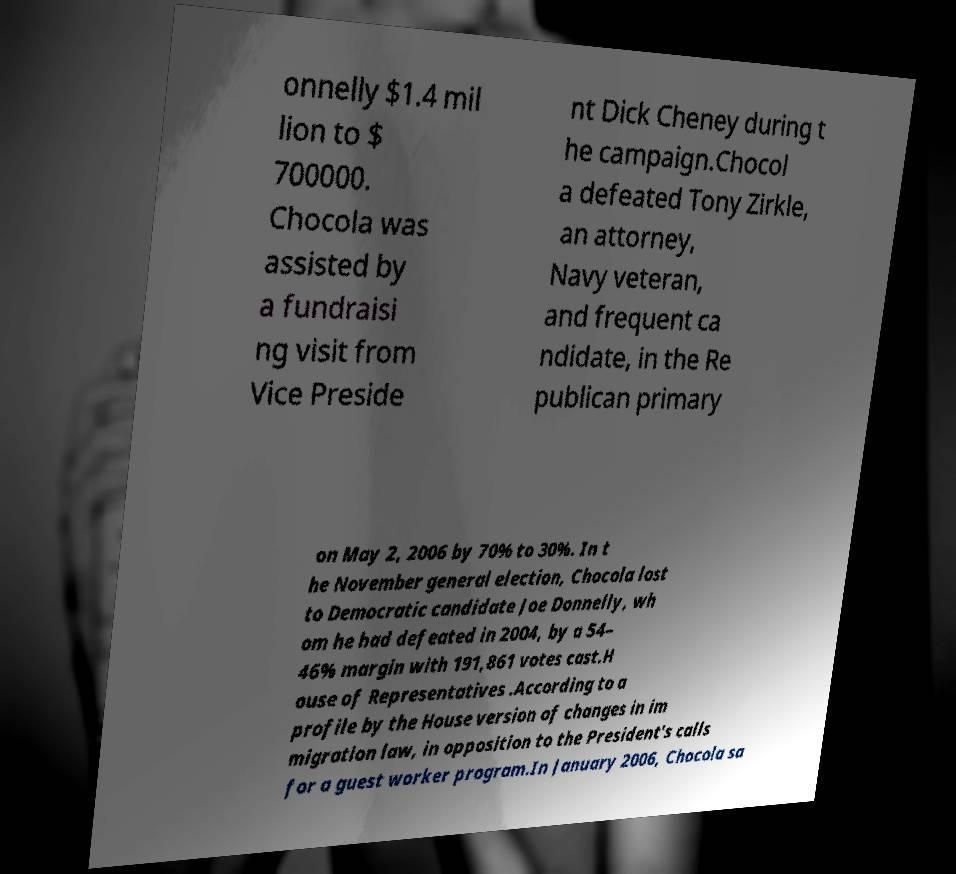Please identify and transcribe the text found in this image. onnelly $1.4 mil lion to $ 700000. Chocola was assisted by a fundraisi ng visit from Vice Preside nt Dick Cheney during t he campaign.Chocol a defeated Tony Zirkle, an attorney, Navy veteran, and frequent ca ndidate, in the Re publican primary on May 2, 2006 by 70% to 30%. In t he November general election, Chocola lost to Democratic candidate Joe Donnelly, wh om he had defeated in 2004, by a 54– 46% margin with 191,861 votes cast.H ouse of Representatives .According to a profile by the House version of changes in im migration law, in opposition to the President's calls for a guest worker program.In January 2006, Chocola sa 